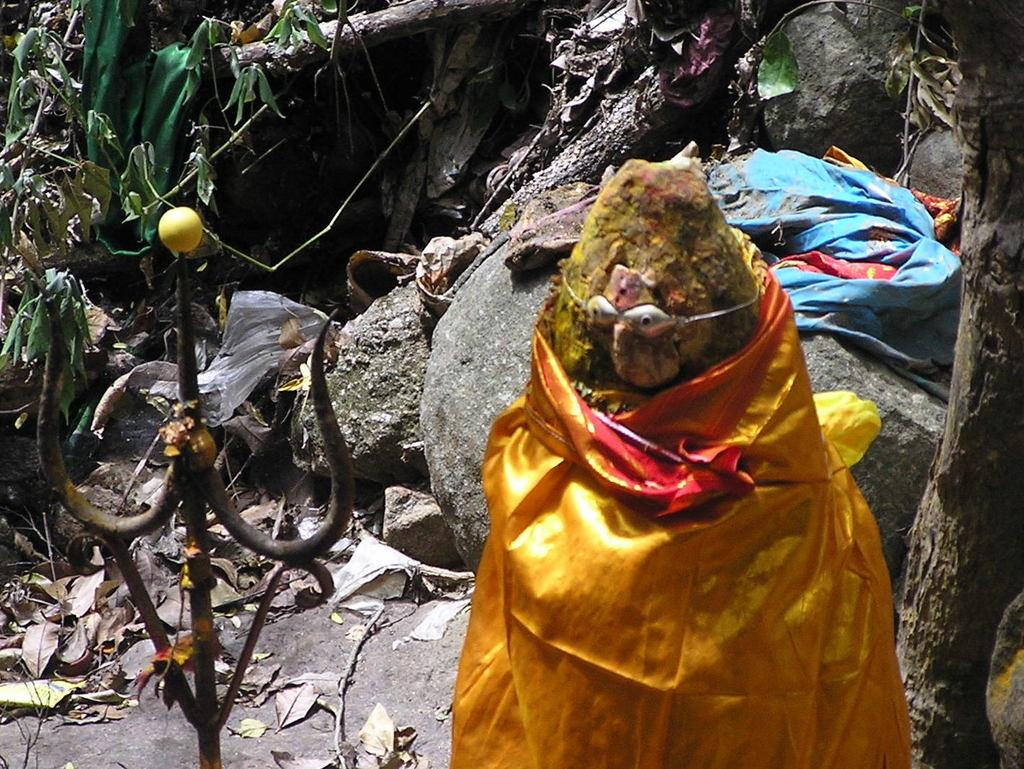What is the main subject of the image? There is a statue in the image. What is covering the statue? The statue is wrapped with cloth. What materials can be seen in the image besides the statue and cloth? Iron rods, shredded leaves, rocks, and plants are present in the image. What type of alarm can be heard going off in the image? There is no alarm present in the image, so no such sound can be heard. 